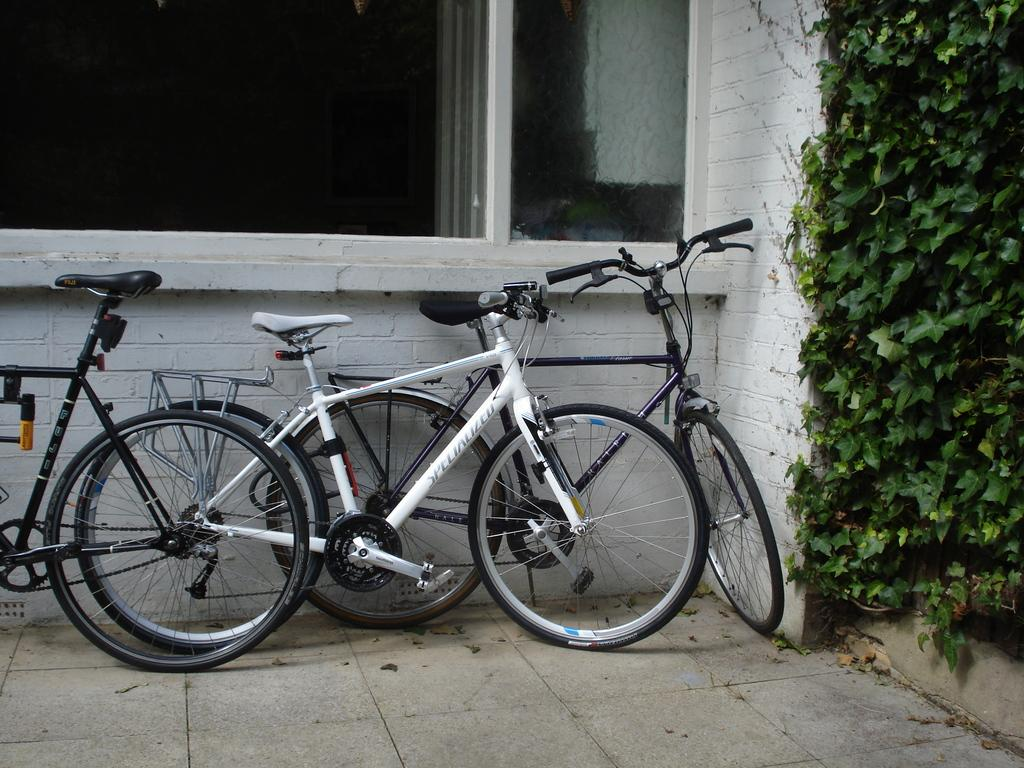What type of vehicles are in the image? There are bicycles in the image. What can be seen in the background of the image? There is a wall in the background of the image. What features are present on the wall? There are doors on the wall. What type of vegetation is on the right side of the image? There are plants on the right side of the image. Can you describe the argument between the bicycles in the image? There is no argument between the bicycles in the image, as bicycles are inanimate objects and cannot engage in arguments. 